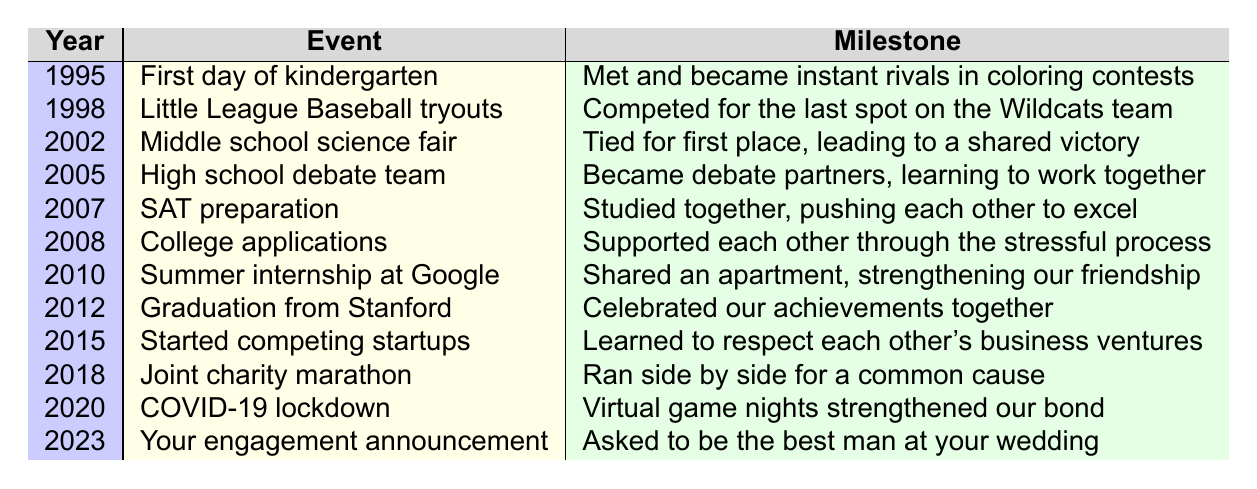What was the first milestone we shared in our friendship journey? The first milestone is from 1995, where we met and became rivals in coloring contests on the first day of kindergarten at Sunshine Elementary.
Answer: Met and became instant rivals in coloring contests Which event occurred right after we tied for first place at the science fair? After the 2002 milestone where we tied for first place at the middle school science fair, the next event occurred in 2005, when we became debate partners.
Answer: Became debate partners Did we ever collaborate on a project during school? Yes, we collaborated during the high school debate team where we became debate partners.
Answer: Yes How many years did it take for us to go from kindergarten to college applications? From kindergarten in 1995 to college applications in 2008 is a span of 13 years (2008 - 1995 = 13).
Answer: 13 years What was the main theme of our joint activities throughout our friendship? Throughout our friendship, the main theme includes competition, collaboration, and support during various stages, as reflected in the milestones such as competing in sports and supporting each other in studies.
Answer: Competition, collaboration, and support When did we support each other through a stressful process, and what was it? We supported each other through the stressful process of college applications in 2008.
Answer: College applications in 2008 Which milestone indicates a significant strengthening of our friendship? The milestone in 2010 when we shared an apartment during our summer internship at Google significantly strengthened our friendship.
Answer: Shared an apartment during our summer internship at Google What was the outcome of our studies together in 2007? Our studies together in 2007 during SAT preparation led us to push each other to excel academically.
Answer: Pushed each other to excel In which year did we start our respective startups? We started competing startups in 2015.
Answer: 2015 Was there a time when we celebrated a significant achievement together? Yes, we celebrated our graduation from Stanford University in 2012, marking a significant achievement for both of us.
Answer: Yes, in 2012 during graduation from Stanford University How many major milestones occurred in our friendship journey between 1995 and 2015? There are 6 major milestones from 1995 to 2015, specifically in the years 1995, 1998, 2002, 2005, 2007, and 2015.
Answer: 6 major milestones 